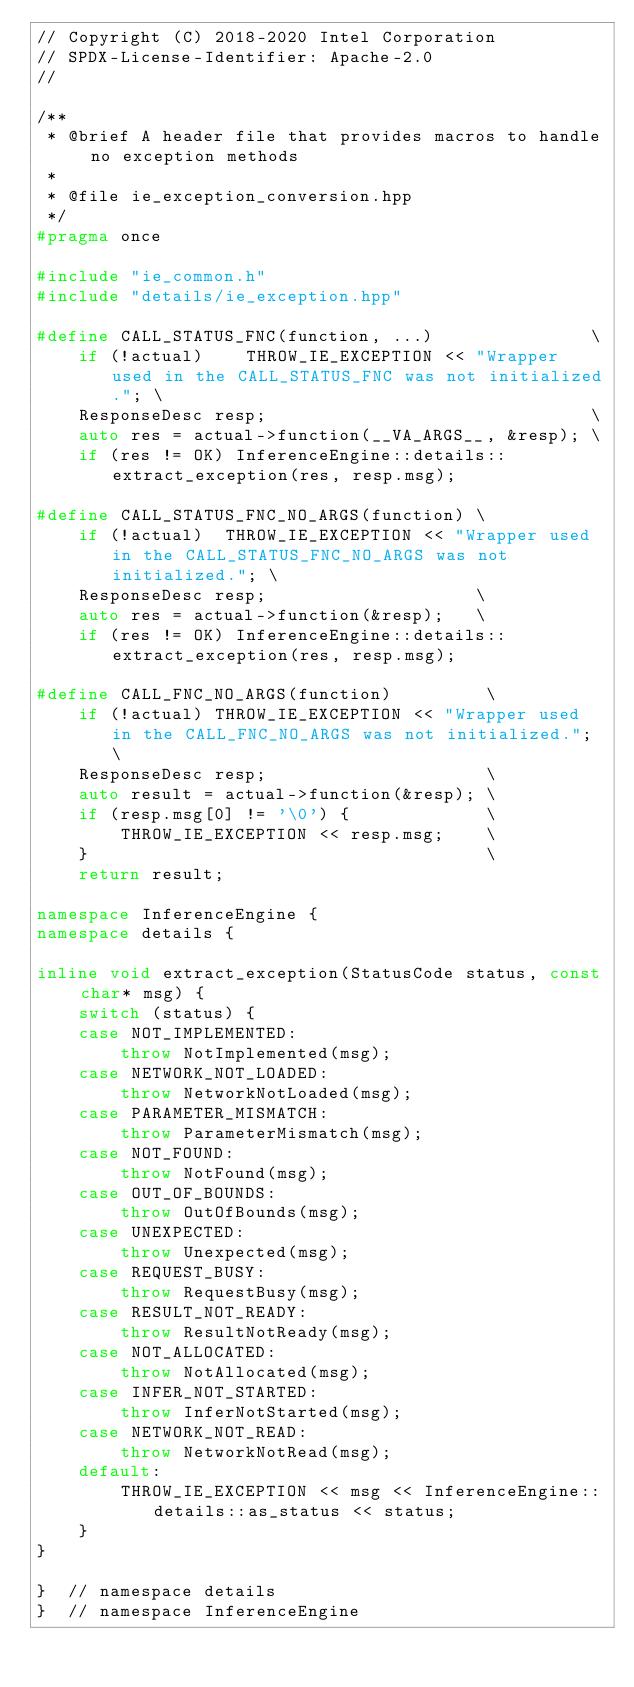Convert code to text. <code><loc_0><loc_0><loc_500><loc_500><_C++_>// Copyright (C) 2018-2020 Intel Corporation
// SPDX-License-Identifier: Apache-2.0
//

/**
 * @brief A header file that provides macros to handle no exception methods
 * 
 * @file ie_exception_conversion.hpp
 */
#pragma once

#include "ie_common.h"
#include "details/ie_exception.hpp"

#define CALL_STATUS_FNC(function, ...)               \
    if (!actual)    THROW_IE_EXCEPTION << "Wrapper used in the CALL_STATUS_FNC was not initialized."; \
    ResponseDesc resp;                               \
    auto res = actual->function(__VA_ARGS__, &resp); \
    if (res != OK) InferenceEngine::details::extract_exception(res, resp.msg);

#define CALL_STATUS_FNC_NO_ARGS(function) \
    if (!actual)  THROW_IE_EXCEPTION << "Wrapper used in the CALL_STATUS_FNC_NO_ARGS was not initialized."; \
    ResponseDesc resp;                    \
    auto res = actual->function(&resp);   \
    if (res != OK) InferenceEngine::details::extract_exception(res, resp.msg);

#define CALL_FNC_NO_ARGS(function)         \
    if (!actual) THROW_IE_EXCEPTION << "Wrapper used in the CALL_FNC_NO_ARGS was not initialized."; \
    ResponseDesc resp;                     \
    auto result = actual->function(&resp); \
    if (resp.msg[0] != '\0') {             \
        THROW_IE_EXCEPTION << resp.msg;    \
    }                                      \
    return result;

namespace InferenceEngine {
namespace details {

inline void extract_exception(StatusCode status, const char* msg) {
    switch (status) {
    case NOT_IMPLEMENTED:
        throw NotImplemented(msg);
    case NETWORK_NOT_LOADED:
        throw NetworkNotLoaded(msg);
    case PARAMETER_MISMATCH:
        throw ParameterMismatch(msg);
    case NOT_FOUND:
        throw NotFound(msg);
    case OUT_OF_BOUNDS:
        throw OutOfBounds(msg);
    case UNEXPECTED:
        throw Unexpected(msg);
    case REQUEST_BUSY:
        throw RequestBusy(msg);
    case RESULT_NOT_READY:
        throw ResultNotReady(msg);
    case NOT_ALLOCATED:
        throw NotAllocated(msg);
    case INFER_NOT_STARTED:
        throw InferNotStarted(msg);
    case NETWORK_NOT_READ:
        throw NetworkNotRead(msg);
    default:
        THROW_IE_EXCEPTION << msg << InferenceEngine::details::as_status << status;
    }
}

}  // namespace details
}  // namespace InferenceEngine
</code> 